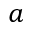<formula> <loc_0><loc_0><loc_500><loc_500>a</formula> 